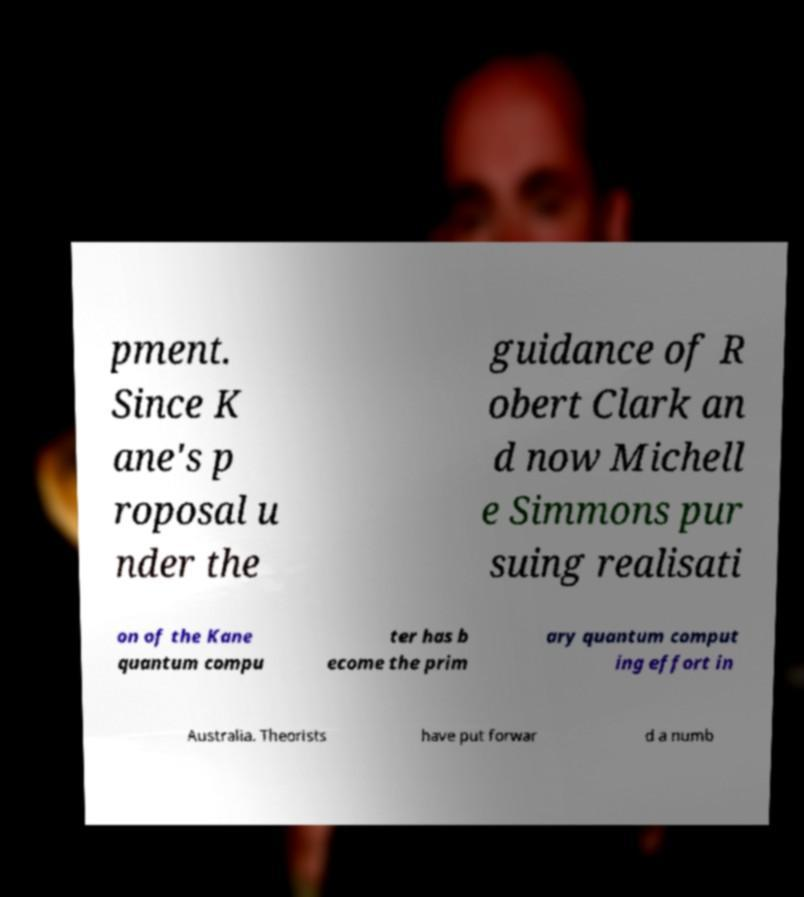I need the written content from this picture converted into text. Can you do that? pment. Since K ane's p roposal u nder the guidance of R obert Clark an d now Michell e Simmons pur suing realisati on of the Kane quantum compu ter has b ecome the prim ary quantum comput ing effort in Australia. Theorists have put forwar d a numb 